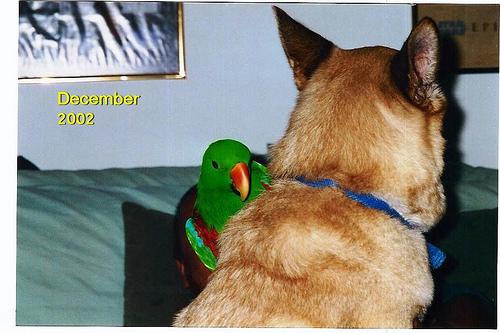How many animals are there?
Write a very short answer. 2. What color is the parrot?
Short answer required. Green. What color is the dog?
Answer briefly. Brown. 